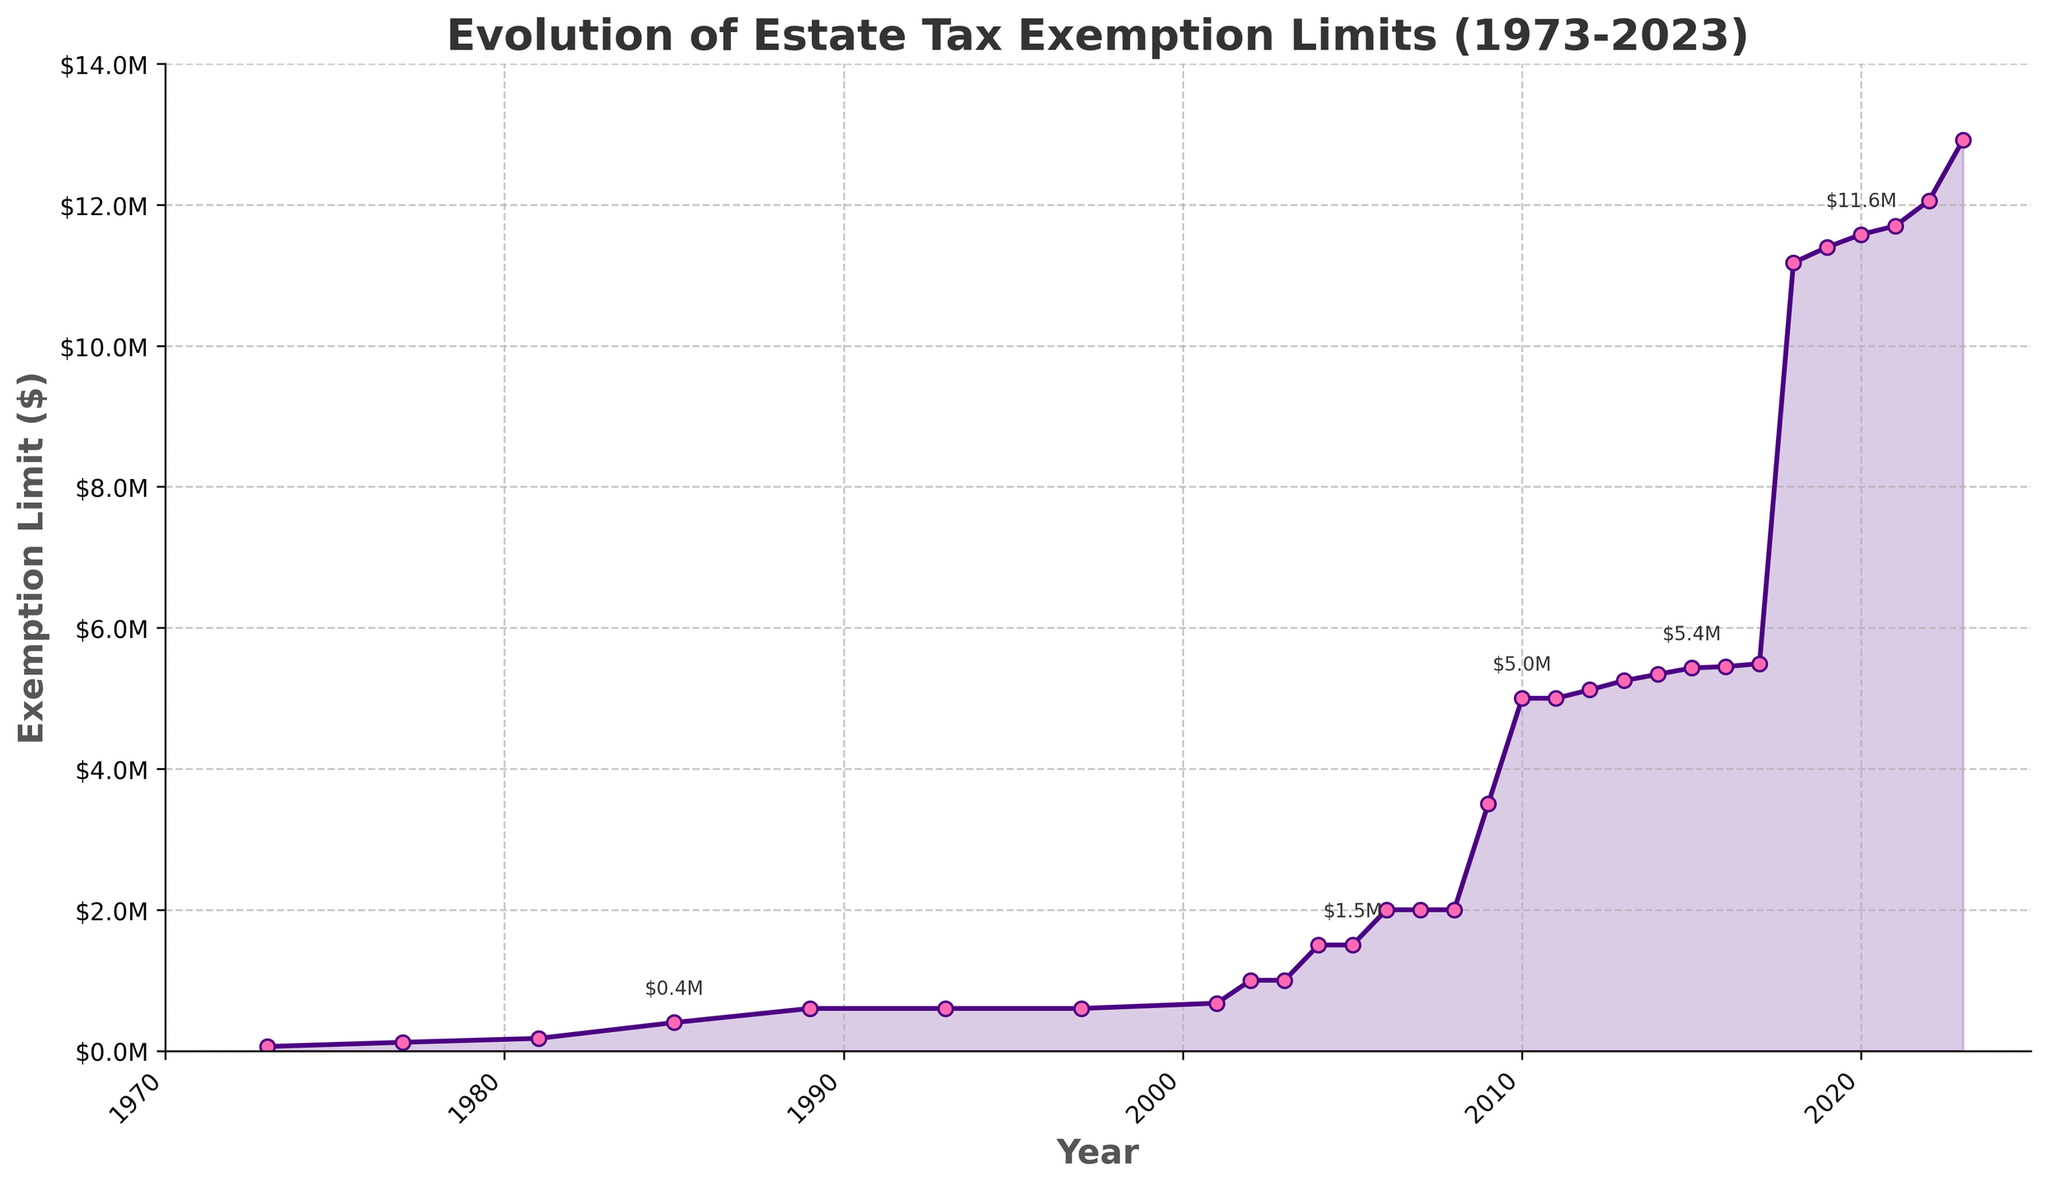What is the general trend of the estate tax exemption limit from 1973 to 2023? The figure shows a clear upward trend in the estate tax exemption limit over the years, especially after 2000, with a sharp increase visible around 2018.
Answer: Upward trend What was the estate tax exemption limit in 1997, and how does it compare to the limit in 2023? The exemption limit in 1997 was $600,000, while in 2023 it was $12,920,000. The limit in 2023 is significantly higher than in 1997.
Answer: 1997: $600,000, 2023: $12,920,000, 2023 is higher In which year did the estate tax exemption limit first exceed $1,000,000? According to the figure, the estate tax exemption limit first exceeded $1,000,000 in the year 2002.
Answer: 2002 How much did the estate tax exemption limit increase from 2009 to 2010? In 2009, the limit was $3,500,000 and increased to $5,000,000 in 2010. The increment is $5,000,000 - $3,500,000 = $1,500,000.
Answer: $1,500,000 During which period was the estate tax exemption limit constant at $600,000? The exemption limit remained constant at $600,000 from 1989 to 2001.
Answer: 1989 to 2001 Compare the estate tax exemption limits between 2007 and 2008. The exemption limits in both 2007 and 2008 were the same, at $2,000,000.
Answer: Same, $2,000,000 Calculate the average increase in the estate tax exemption limit per year between 2001 and 2023. From 2001 ($675,000) to 2023 ($12,920,000), the total increase is $12,920,000 - $675,000 = $12,245,000. Dividing this by the number of years (2023 - 2001 = 22 years), the average increase is $12,245,000 / 22 ≈ $556,591 per year.
Answer: ≈ $556,591 per year Identify the period when the estate tax exemption limit doubled in the shortest time span. The limit doubled from $5,450,000 in 2017 to $11,180,000 in 2018, within 1 year.
Answer: 2017 to 2018 What was the estate tax exemption limit in 1981, and how did it change by 1985? In 1981, the limit was $175,625. By 1985, it had increased to $400,000.
Answer: 1981: $175,625, 1985: $400,000 